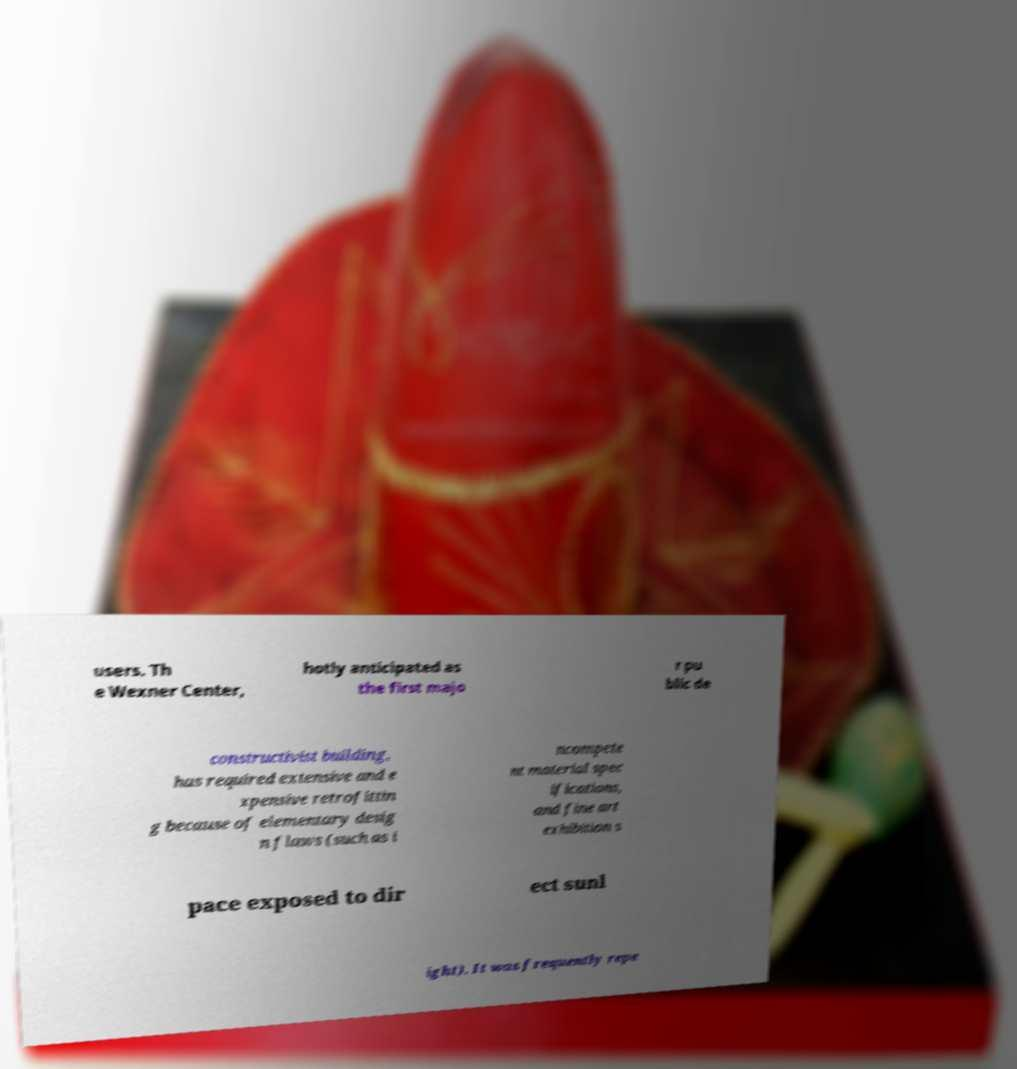There's text embedded in this image that I need extracted. Can you transcribe it verbatim? users. Th e Wexner Center, hotly anticipated as the first majo r pu blic de constructivist building, has required extensive and e xpensive retrofittin g because of elementary desig n flaws (such as i ncompete nt material spec ifications, and fine art exhibition s pace exposed to dir ect sunl ight). It was frequently repe 